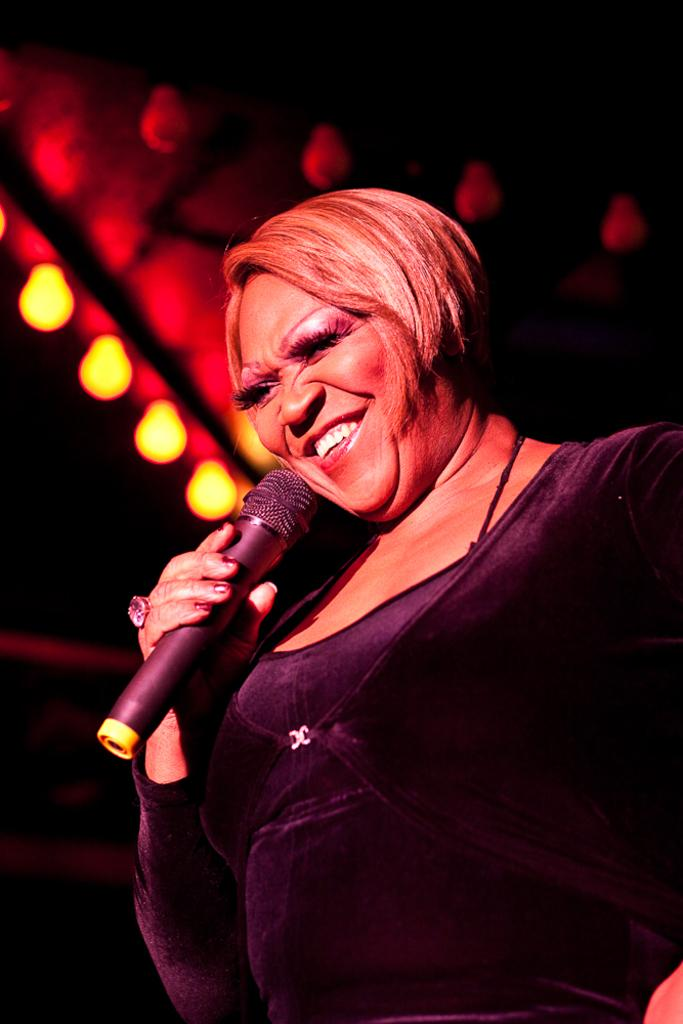Who is the main subject in the image? There is a woman in the image. What is the woman holding in the image? The woman is holding a mic. What expression does the woman have in the image? The woman is smiling. What can be seen in the background of the image? There are bulbs in the background of the image. What type of authority does the woman have in the image? There is no indication of the woman's authority in the image. How does the growth of the potato relate to the image? There is no potato present in the image, so its growth is not relevant. 